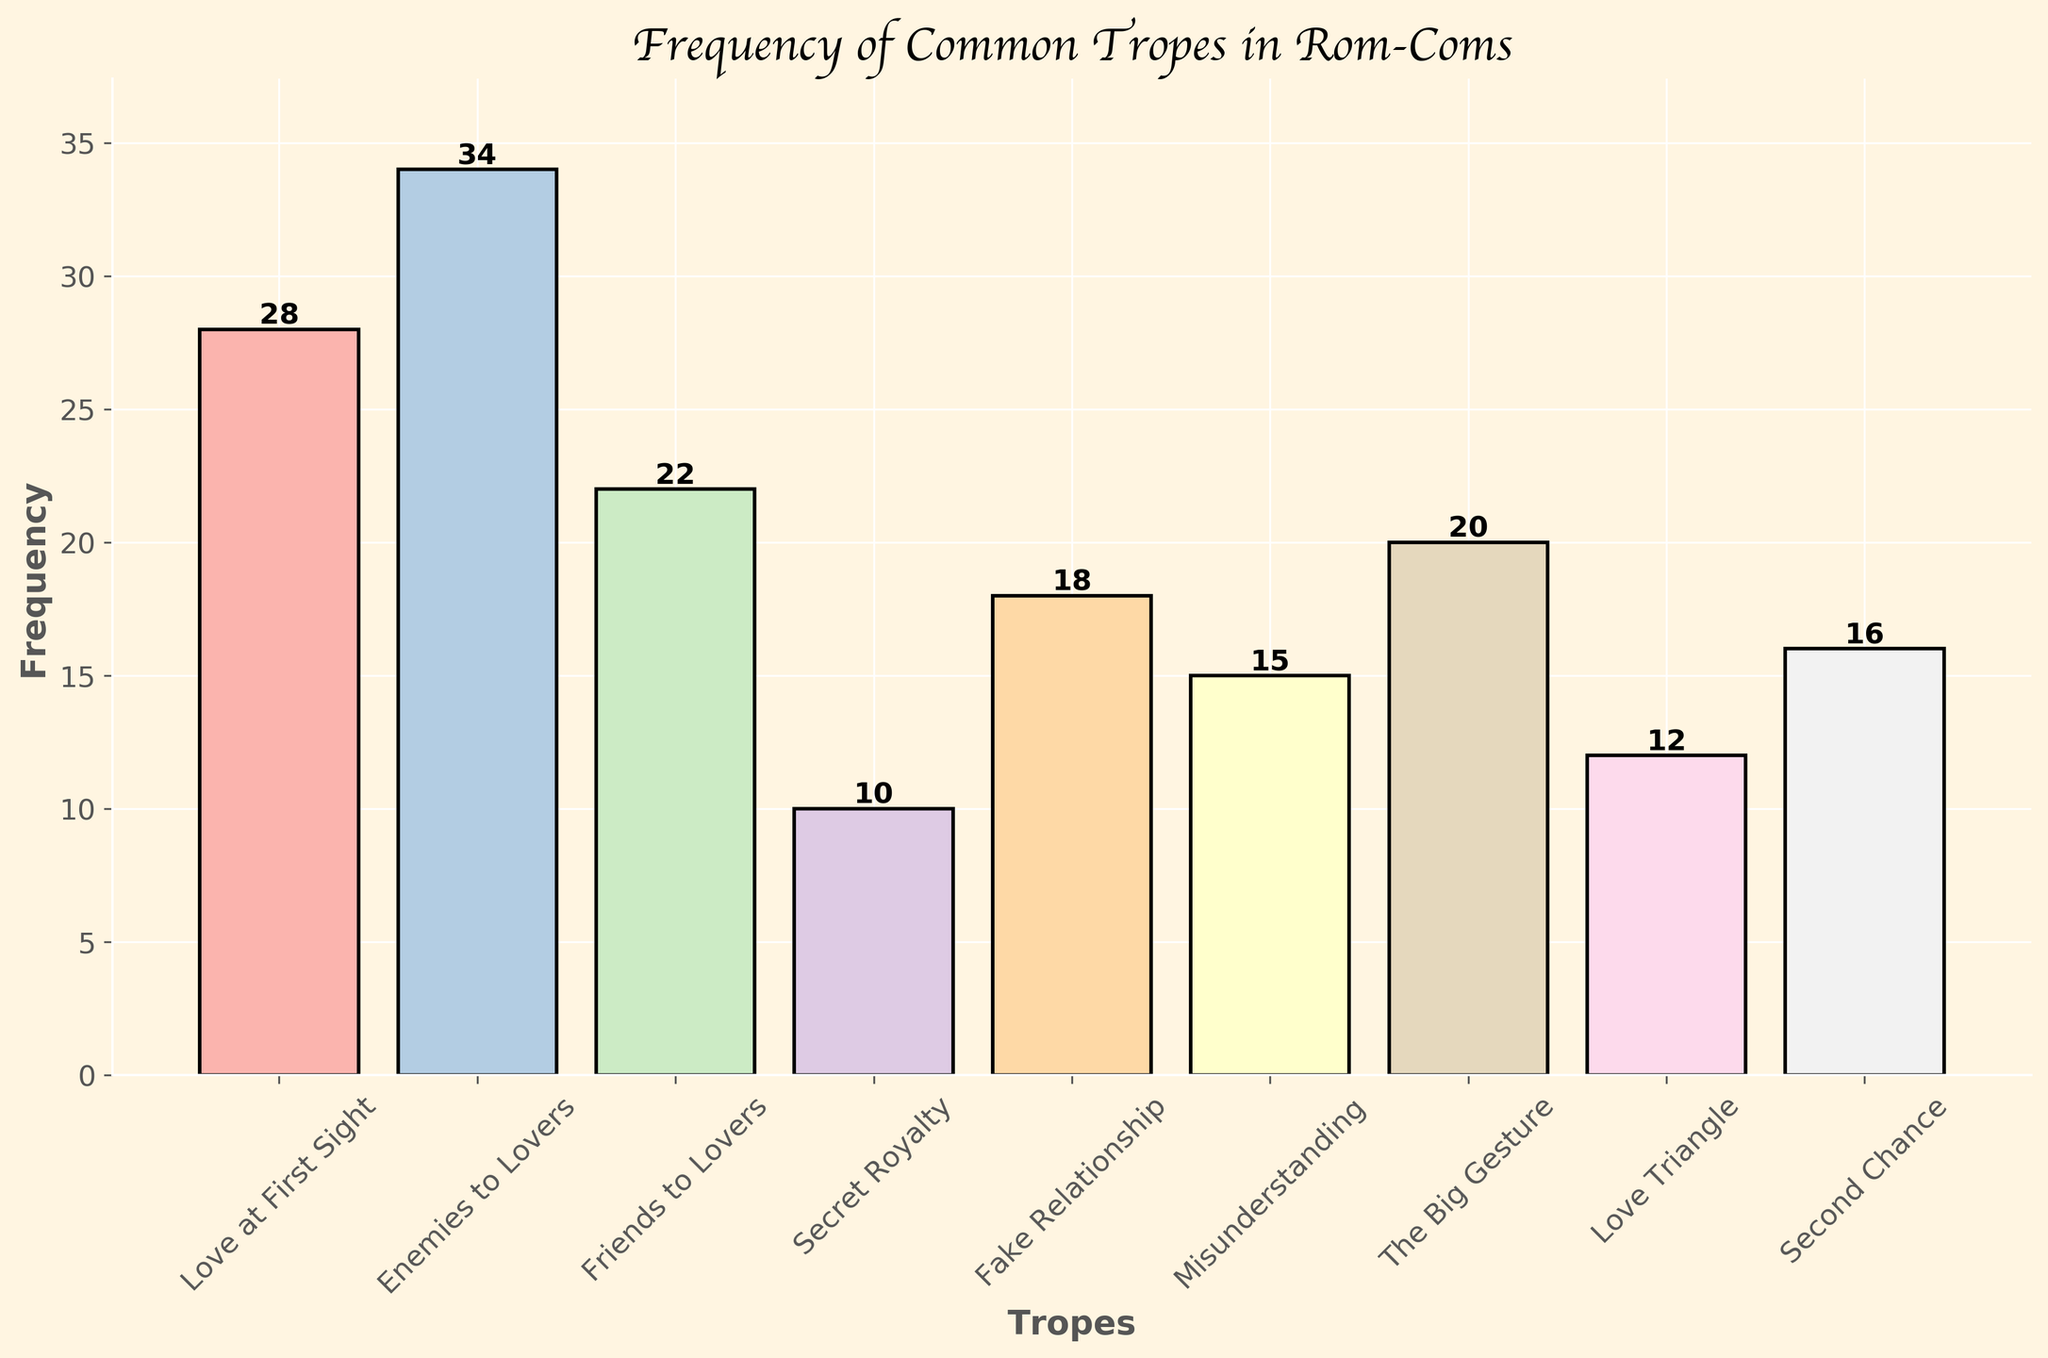What is the most common trope displayed in the figure? First, look at the bar chart to see which trope has the highest frequency. "Enemies to Lovers" has the tallest bar, indicating it is the most common trope.
Answer: Enemies to Lovers What is the difference in frequency between the most and least common tropes? Identify the most common trope ("Enemies to Lovers" with 34) and the least common trope ("Secret Royalty" with 10). Subtract the frequency of the least common trope from the most common trope: 34 - 10 = 24.
Answer: 24 How many tropes have a frequency of 20 or higher? Check the bars to count how many have frequencies equal to or greater than 20. "Enemies to Lovers" (34), "Love at First Sight" (28), "Friends to Lovers" (22), and "The Big Gesture" (20) meet the criteria.
Answer: 4 Which trope has a frequency closest to the average frequency of all tropes? First, find the average frequency: (28 + 34 + 22 + 10 + 18 + 15 + 20 + 12 + 16) / 9 = 19.22. Then, compare each trope's frequency to see which is closest to 19.22. "The Big Gesture" with 20 is the closest.
Answer: The Big Gesture How does the frequency of "Fake Relationship" compare to "Misunderstanding"? Check the frequency of "Fake Relationship" (18) and "Misunderstanding" (15). Compare the two values to see that "Fake Relationship" has a higher frequency.
Answer: Fake Relationship > Misunderstanding Which bars are labeled with values larger than 25? Look at the bar chart for values written above the bars. The bars for "Enemies to Lovers" (34) and "Love at First Sight" (28) have values larger than 25.
Answer: Enemies to Lovers and Love at First Sight What is the total frequency of tropes that are associated with "Love"? Sum the frequencies of tropes that contain "Love": "Love at First Sight" (28), "Friends to Lovers" (22), "Second Chance" (16) encompass the concept of love. 28 + 22 + 16 = 66.
Answer: 66 